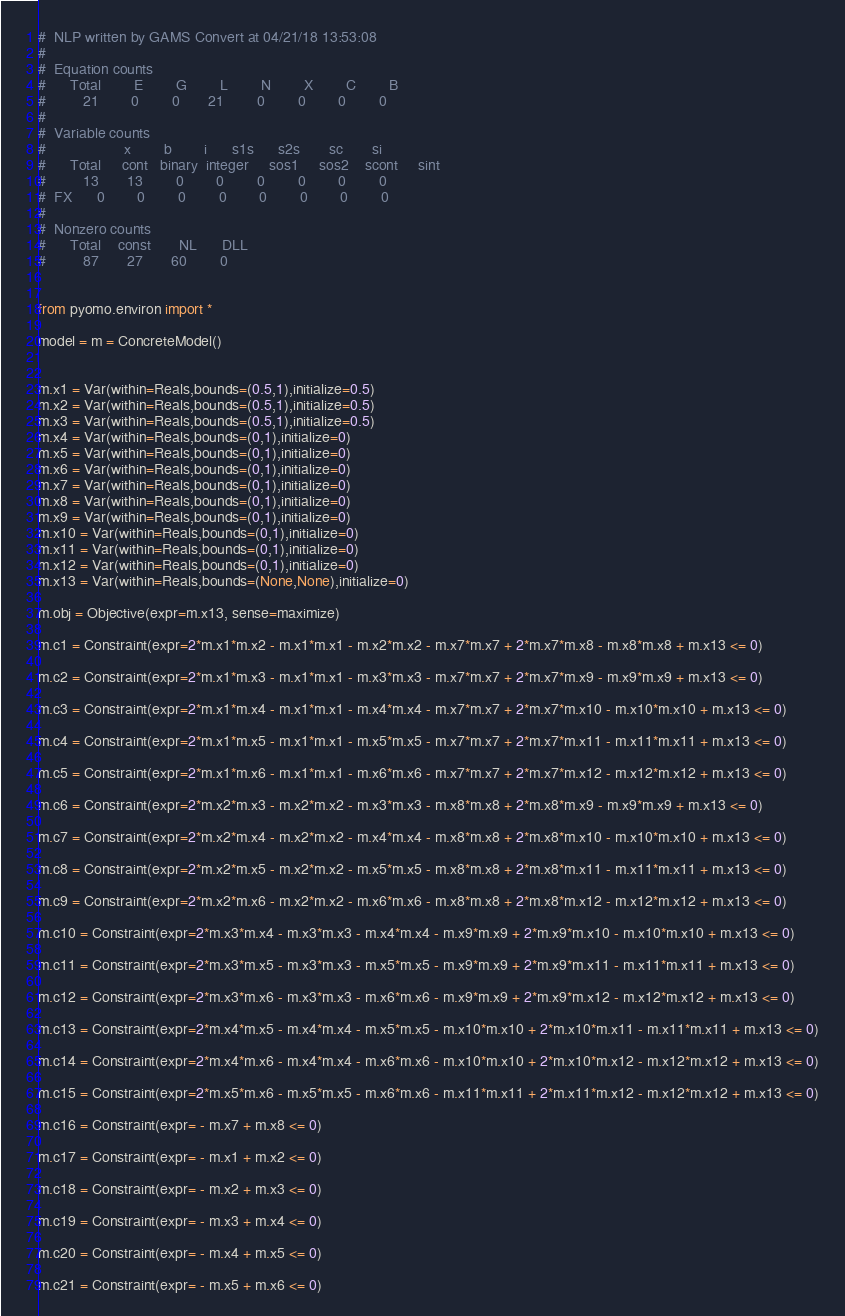<code> <loc_0><loc_0><loc_500><loc_500><_Python_>#  NLP written by GAMS Convert at 04/21/18 13:53:08
#  
#  Equation counts
#      Total        E        G        L        N        X        C        B
#         21        0        0       21        0        0        0        0
#  
#  Variable counts
#                   x        b        i      s1s      s2s       sc       si
#      Total     cont   binary  integer     sos1     sos2    scont     sint
#         13       13        0        0        0        0        0        0
#  FX      0        0        0        0        0        0        0        0
#  
#  Nonzero counts
#      Total    const       NL      DLL
#         87       27       60        0


from pyomo.environ import *

model = m = ConcreteModel()


m.x1 = Var(within=Reals,bounds=(0.5,1),initialize=0.5)
m.x2 = Var(within=Reals,bounds=(0.5,1),initialize=0.5)
m.x3 = Var(within=Reals,bounds=(0.5,1),initialize=0.5)
m.x4 = Var(within=Reals,bounds=(0,1),initialize=0)
m.x5 = Var(within=Reals,bounds=(0,1),initialize=0)
m.x6 = Var(within=Reals,bounds=(0,1),initialize=0)
m.x7 = Var(within=Reals,bounds=(0,1),initialize=0)
m.x8 = Var(within=Reals,bounds=(0,1),initialize=0)
m.x9 = Var(within=Reals,bounds=(0,1),initialize=0)
m.x10 = Var(within=Reals,bounds=(0,1),initialize=0)
m.x11 = Var(within=Reals,bounds=(0,1),initialize=0)
m.x12 = Var(within=Reals,bounds=(0,1),initialize=0)
m.x13 = Var(within=Reals,bounds=(None,None),initialize=0)

m.obj = Objective(expr=m.x13, sense=maximize)

m.c1 = Constraint(expr=2*m.x1*m.x2 - m.x1*m.x1 - m.x2*m.x2 - m.x7*m.x7 + 2*m.x7*m.x8 - m.x8*m.x8 + m.x13 <= 0)

m.c2 = Constraint(expr=2*m.x1*m.x3 - m.x1*m.x1 - m.x3*m.x3 - m.x7*m.x7 + 2*m.x7*m.x9 - m.x9*m.x9 + m.x13 <= 0)

m.c3 = Constraint(expr=2*m.x1*m.x4 - m.x1*m.x1 - m.x4*m.x4 - m.x7*m.x7 + 2*m.x7*m.x10 - m.x10*m.x10 + m.x13 <= 0)

m.c4 = Constraint(expr=2*m.x1*m.x5 - m.x1*m.x1 - m.x5*m.x5 - m.x7*m.x7 + 2*m.x7*m.x11 - m.x11*m.x11 + m.x13 <= 0)

m.c5 = Constraint(expr=2*m.x1*m.x6 - m.x1*m.x1 - m.x6*m.x6 - m.x7*m.x7 + 2*m.x7*m.x12 - m.x12*m.x12 + m.x13 <= 0)

m.c6 = Constraint(expr=2*m.x2*m.x3 - m.x2*m.x2 - m.x3*m.x3 - m.x8*m.x8 + 2*m.x8*m.x9 - m.x9*m.x9 + m.x13 <= 0)

m.c7 = Constraint(expr=2*m.x2*m.x4 - m.x2*m.x2 - m.x4*m.x4 - m.x8*m.x8 + 2*m.x8*m.x10 - m.x10*m.x10 + m.x13 <= 0)

m.c8 = Constraint(expr=2*m.x2*m.x5 - m.x2*m.x2 - m.x5*m.x5 - m.x8*m.x8 + 2*m.x8*m.x11 - m.x11*m.x11 + m.x13 <= 0)

m.c9 = Constraint(expr=2*m.x2*m.x6 - m.x2*m.x2 - m.x6*m.x6 - m.x8*m.x8 + 2*m.x8*m.x12 - m.x12*m.x12 + m.x13 <= 0)

m.c10 = Constraint(expr=2*m.x3*m.x4 - m.x3*m.x3 - m.x4*m.x4 - m.x9*m.x9 + 2*m.x9*m.x10 - m.x10*m.x10 + m.x13 <= 0)

m.c11 = Constraint(expr=2*m.x3*m.x5 - m.x3*m.x3 - m.x5*m.x5 - m.x9*m.x9 + 2*m.x9*m.x11 - m.x11*m.x11 + m.x13 <= 0)

m.c12 = Constraint(expr=2*m.x3*m.x6 - m.x3*m.x3 - m.x6*m.x6 - m.x9*m.x9 + 2*m.x9*m.x12 - m.x12*m.x12 + m.x13 <= 0)

m.c13 = Constraint(expr=2*m.x4*m.x5 - m.x4*m.x4 - m.x5*m.x5 - m.x10*m.x10 + 2*m.x10*m.x11 - m.x11*m.x11 + m.x13 <= 0)

m.c14 = Constraint(expr=2*m.x4*m.x6 - m.x4*m.x4 - m.x6*m.x6 - m.x10*m.x10 + 2*m.x10*m.x12 - m.x12*m.x12 + m.x13 <= 0)

m.c15 = Constraint(expr=2*m.x5*m.x6 - m.x5*m.x5 - m.x6*m.x6 - m.x11*m.x11 + 2*m.x11*m.x12 - m.x12*m.x12 + m.x13 <= 0)

m.c16 = Constraint(expr= - m.x7 + m.x8 <= 0)

m.c17 = Constraint(expr= - m.x1 + m.x2 <= 0)

m.c18 = Constraint(expr= - m.x2 + m.x3 <= 0)

m.c19 = Constraint(expr= - m.x3 + m.x4 <= 0)

m.c20 = Constraint(expr= - m.x4 + m.x5 <= 0)

m.c21 = Constraint(expr= - m.x5 + m.x6 <= 0)
</code> 